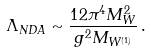Convert formula to latex. <formula><loc_0><loc_0><loc_500><loc_500>\Lambda _ { N D A } \sim \frac { 1 2 \pi ^ { 4 } M _ { W } ^ { 2 } } { g ^ { 2 } M _ { W ^ { ( 1 ) } } } \, .</formula> 